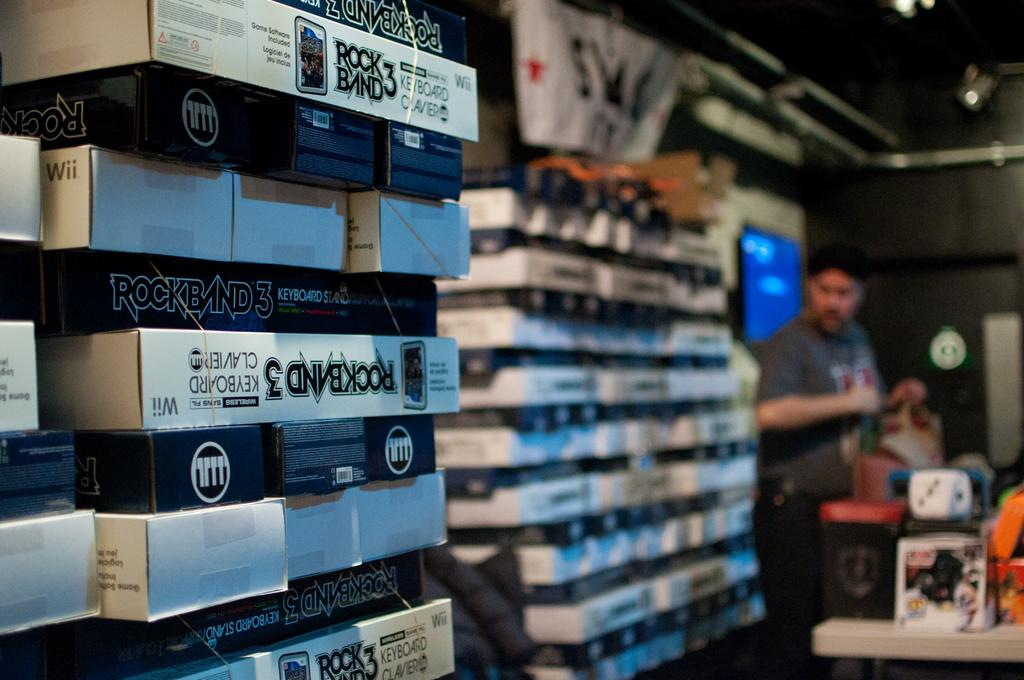<image>
Relay a brief, clear account of the picture shown. boxes of games with the name 'rockband 3' on them 